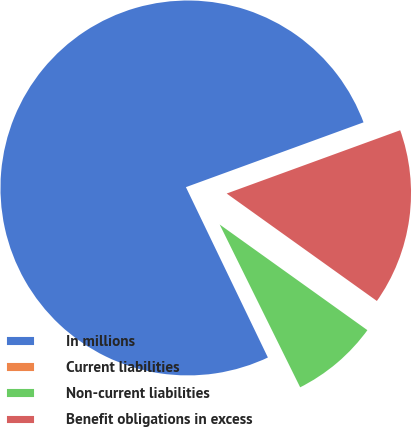<chart> <loc_0><loc_0><loc_500><loc_500><pie_chart><fcel>In millions<fcel>Current liabilities<fcel>Non-current liabilities<fcel>Benefit obligations in excess<nl><fcel>76.58%<fcel>0.17%<fcel>7.81%<fcel>15.45%<nl></chart> 